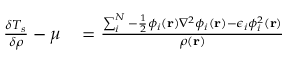<formula> <loc_0><loc_0><loc_500><loc_500>\begin{array} { r l } { \frac { \delta T _ { s } } { \delta \rho } - \mu } & = \frac { \sum _ { i } ^ { N } - \frac { 1 } { 2 } \phi _ { i } ( r ) \nabla ^ { 2 } \phi _ { i } ( r ) - \epsilon _ { i } \phi _ { i } ^ { 2 } ( r ) } { \rho ( r ) } } \end{array}</formula> 